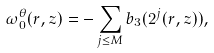<formula> <loc_0><loc_0><loc_500><loc_500>\omega _ { 0 } ^ { \theta } ( r , z ) = - \sum _ { j \leq M } b _ { 3 } ( 2 ^ { j } ( r , z ) ) ,</formula> 